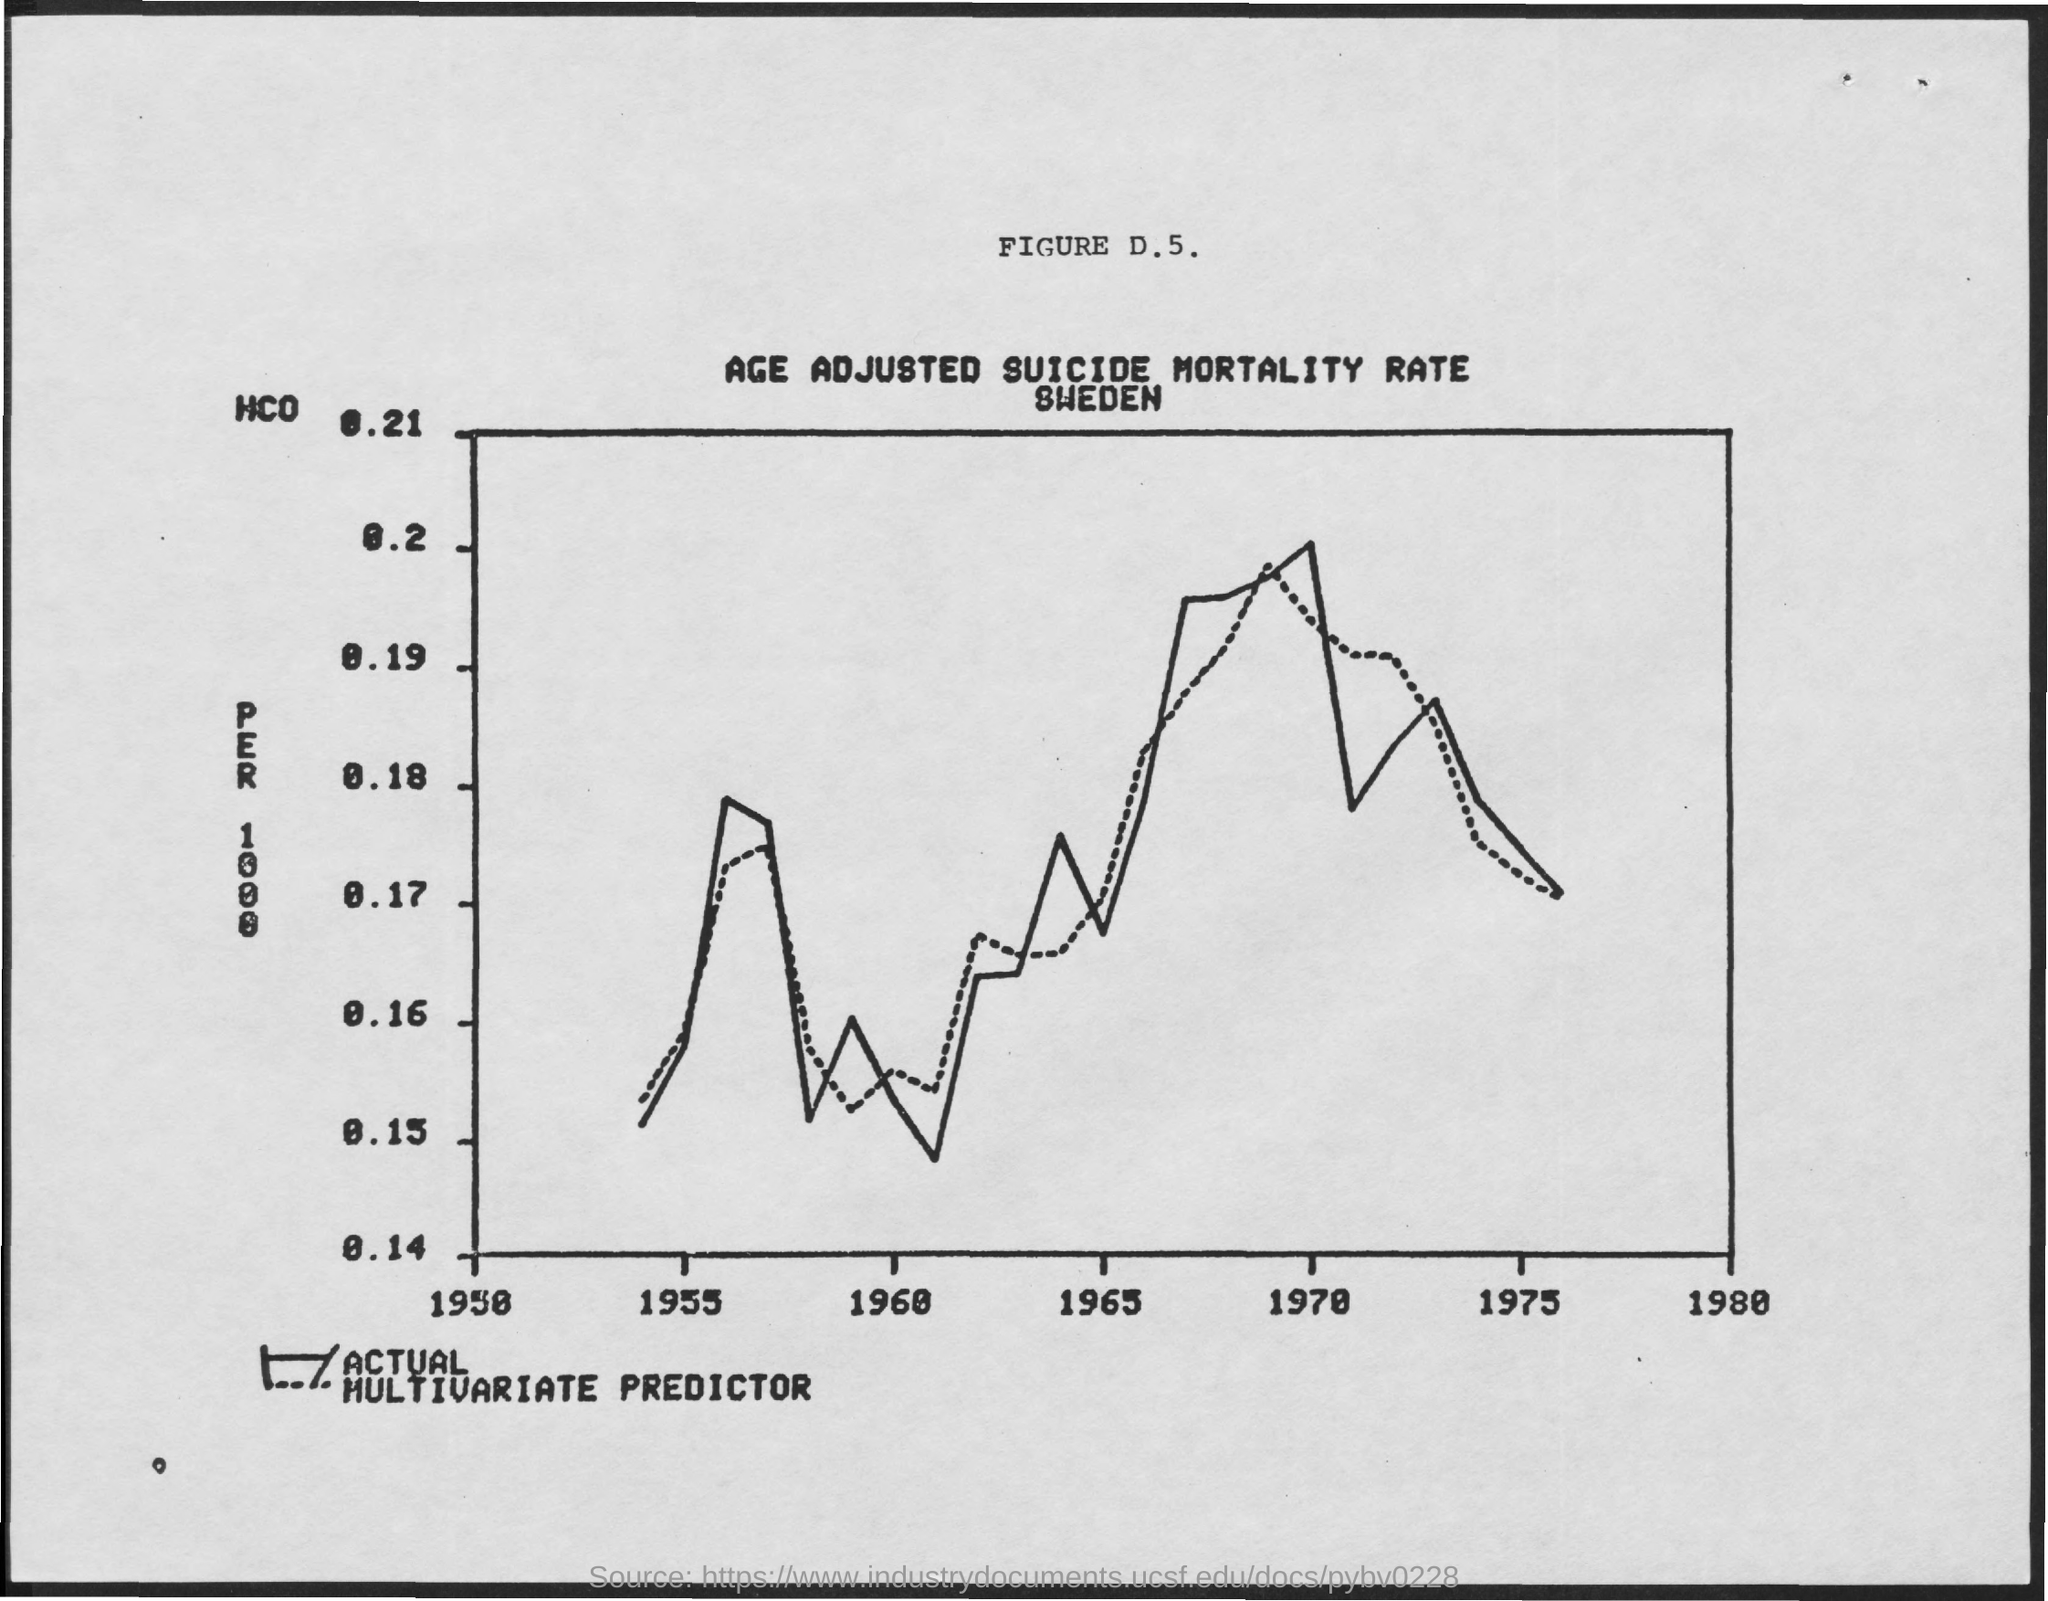Highlight a few significant elements in this photo. The figure number mentioned is D.5. The title of the figure is the age-adjusted suicide mortality rate in Sweden. 